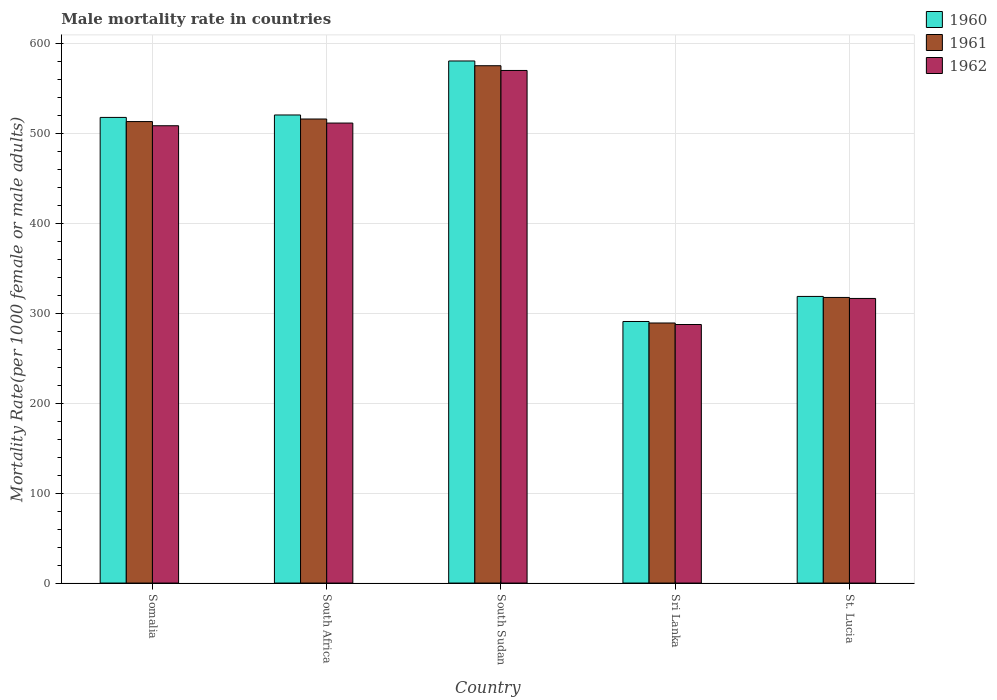How many different coloured bars are there?
Your answer should be very brief. 3. How many groups of bars are there?
Make the answer very short. 5. Are the number of bars on each tick of the X-axis equal?
Offer a very short reply. Yes. What is the label of the 5th group of bars from the left?
Your response must be concise. St. Lucia. In how many cases, is the number of bars for a given country not equal to the number of legend labels?
Make the answer very short. 0. What is the male mortality rate in 1960 in Somalia?
Your answer should be very brief. 517.62. Across all countries, what is the maximum male mortality rate in 1961?
Ensure brevity in your answer.  575.08. Across all countries, what is the minimum male mortality rate in 1962?
Provide a short and direct response. 287.41. In which country was the male mortality rate in 1961 maximum?
Make the answer very short. South Sudan. In which country was the male mortality rate in 1960 minimum?
Your response must be concise. Sri Lanka. What is the total male mortality rate in 1961 in the graph?
Offer a terse response. 2210.49. What is the difference between the male mortality rate in 1960 in South Sudan and that in Sri Lanka?
Your answer should be very brief. 289.59. What is the difference between the male mortality rate in 1960 in South Sudan and the male mortality rate in 1961 in Somalia?
Provide a succinct answer. 67.36. What is the average male mortality rate in 1961 per country?
Keep it short and to the point. 442.1. What is the difference between the male mortality rate of/in 1960 and male mortality rate of/in 1962 in Sri Lanka?
Your answer should be very brief. 3.35. What is the ratio of the male mortality rate in 1960 in Somalia to that in St. Lucia?
Ensure brevity in your answer.  1.62. Is the difference between the male mortality rate in 1960 in South Sudan and Sri Lanka greater than the difference between the male mortality rate in 1962 in South Sudan and Sri Lanka?
Offer a very short reply. Yes. What is the difference between the highest and the second highest male mortality rate in 1962?
Keep it short and to the point. 61.46. What is the difference between the highest and the lowest male mortality rate in 1962?
Offer a terse response. 282.4. In how many countries, is the male mortality rate in 1962 greater than the average male mortality rate in 1962 taken over all countries?
Your answer should be compact. 3. Is the sum of the male mortality rate in 1960 in Somalia and South Africa greater than the maximum male mortality rate in 1961 across all countries?
Offer a terse response. Yes. What does the 1st bar from the right in St. Lucia represents?
Offer a terse response. 1962. Is it the case that in every country, the sum of the male mortality rate in 1961 and male mortality rate in 1962 is greater than the male mortality rate in 1960?
Provide a short and direct response. Yes. How many bars are there?
Offer a very short reply. 15. How many countries are there in the graph?
Keep it short and to the point. 5. What is the difference between two consecutive major ticks on the Y-axis?
Your response must be concise. 100. Are the values on the major ticks of Y-axis written in scientific E-notation?
Offer a very short reply. No. Does the graph contain any zero values?
Ensure brevity in your answer.  No. Where does the legend appear in the graph?
Keep it short and to the point. Top right. What is the title of the graph?
Provide a short and direct response. Male mortality rate in countries. Does "1971" appear as one of the legend labels in the graph?
Offer a terse response. No. What is the label or title of the Y-axis?
Give a very brief answer. Mortality Rate(per 1000 female or male adults). What is the Mortality Rate(per 1000 female or male adults) of 1960 in Somalia?
Make the answer very short. 517.62. What is the Mortality Rate(per 1000 female or male adults) of 1961 in Somalia?
Your answer should be compact. 512.99. What is the Mortality Rate(per 1000 female or male adults) of 1962 in Somalia?
Offer a very short reply. 508.35. What is the Mortality Rate(per 1000 female or male adults) in 1960 in South Africa?
Your response must be concise. 520.32. What is the Mortality Rate(per 1000 female or male adults) of 1961 in South Africa?
Your response must be concise. 515.84. What is the Mortality Rate(per 1000 female or male adults) in 1962 in South Africa?
Your answer should be very brief. 511.35. What is the Mortality Rate(per 1000 female or male adults) in 1960 in South Sudan?
Provide a short and direct response. 580.35. What is the Mortality Rate(per 1000 female or male adults) of 1961 in South Sudan?
Your answer should be compact. 575.08. What is the Mortality Rate(per 1000 female or male adults) of 1962 in South Sudan?
Make the answer very short. 569.81. What is the Mortality Rate(per 1000 female or male adults) in 1960 in Sri Lanka?
Provide a succinct answer. 290.76. What is the Mortality Rate(per 1000 female or male adults) of 1961 in Sri Lanka?
Offer a very short reply. 289.09. What is the Mortality Rate(per 1000 female or male adults) of 1962 in Sri Lanka?
Your answer should be compact. 287.41. What is the Mortality Rate(per 1000 female or male adults) in 1960 in St. Lucia?
Provide a succinct answer. 318.62. What is the Mortality Rate(per 1000 female or male adults) in 1961 in St. Lucia?
Offer a very short reply. 317.49. What is the Mortality Rate(per 1000 female or male adults) in 1962 in St. Lucia?
Give a very brief answer. 316.37. Across all countries, what is the maximum Mortality Rate(per 1000 female or male adults) in 1960?
Keep it short and to the point. 580.35. Across all countries, what is the maximum Mortality Rate(per 1000 female or male adults) of 1961?
Offer a very short reply. 575.08. Across all countries, what is the maximum Mortality Rate(per 1000 female or male adults) in 1962?
Ensure brevity in your answer.  569.81. Across all countries, what is the minimum Mortality Rate(per 1000 female or male adults) in 1960?
Offer a very short reply. 290.76. Across all countries, what is the minimum Mortality Rate(per 1000 female or male adults) of 1961?
Your answer should be very brief. 289.09. Across all countries, what is the minimum Mortality Rate(per 1000 female or male adults) in 1962?
Provide a short and direct response. 287.41. What is the total Mortality Rate(per 1000 female or male adults) of 1960 in the graph?
Keep it short and to the point. 2227.67. What is the total Mortality Rate(per 1000 female or male adults) of 1961 in the graph?
Your answer should be compact. 2210.49. What is the total Mortality Rate(per 1000 female or male adults) in 1962 in the graph?
Your response must be concise. 2193.3. What is the difference between the Mortality Rate(per 1000 female or male adults) in 1960 in Somalia and that in South Africa?
Keep it short and to the point. -2.69. What is the difference between the Mortality Rate(per 1000 female or male adults) in 1961 in Somalia and that in South Africa?
Make the answer very short. -2.85. What is the difference between the Mortality Rate(per 1000 female or male adults) of 1962 in Somalia and that in South Africa?
Your answer should be very brief. -3. What is the difference between the Mortality Rate(per 1000 female or male adults) of 1960 in Somalia and that in South Sudan?
Make the answer very short. -62.73. What is the difference between the Mortality Rate(per 1000 female or male adults) of 1961 in Somalia and that in South Sudan?
Make the answer very short. -62.09. What is the difference between the Mortality Rate(per 1000 female or male adults) of 1962 in Somalia and that in South Sudan?
Offer a very short reply. -61.46. What is the difference between the Mortality Rate(per 1000 female or male adults) in 1960 in Somalia and that in Sri Lanka?
Offer a very short reply. 226.86. What is the difference between the Mortality Rate(per 1000 female or male adults) of 1961 in Somalia and that in Sri Lanka?
Your response must be concise. 223.9. What is the difference between the Mortality Rate(per 1000 female or male adults) of 1962 in Somalia and that in Sri Lanka?
Your response must be concise. 220.94. What is the difference between the Mortality Rate(per 1000 female or male adults) in 1960 in Somalia and that in St. Lucia?
Your response must be concise. 199.01. What is the difference between the Mortality Rate(per 1000 female or male adults) of 1961 in Somalia and that in St. Lucia?
Ensure brevity in your answer.  195.5. What is the difference between the Mortality Rate(per 1000 female or male adults) of 1962 in Somalia and that in St. Lucia?
Give a very brief answer. 191.98. What is the difference between the Mortality Rate(per 1000 female or male adults) of 1960 in South Africa and that in South Sudan?
Keep it short and to the point. -60.03. What is the difference between the Mortality Rate(per 1000 female or male adults) in 1961 in South Africa and that in South Sudan?
Offer a terse response. -59.24. What is the difference between the Mortality Rate(per 1000 female or male adults) in 1962 in South Africa and that in South Sudan?
Provide a succinct answer. -58.45. What is the difference between the Mortality Rate(per 1000 female or male adults) of 1960 in South Africa and that in Sri Lanka?
Provide a short and direct response. 229.56. What is the difference between the Mortality Rate(per 1000 female or male adults) in 1961 in South Africa and that in Sri Lanka?
Offer a terse response. 226.75. What is the difference between the Mortality Rate(per 1000 female or male adults) in 1962 in South Africa and that in Sri Lanka?
Make the answer very short. 223.94. What is the difference between the Mortality Rate(per 1000 female or male adults) in 1960 in South Africa and that in St. Lucia?
Your response must be concise. 201.7. What is the difference between the Mortality Rate(per 1000 female or male adults) of 1961 in South Africa and that in St. Lucia?
Make the answer very short. 198.34. What is the difference between the Mortality Rate(per 1000 female or male adults) in 1962 in South Africa and that in St. Lucia?
Keep it short and to the point. 194.98. What is the difference between the Mortality Rate(per 1000 female or male adults) of 1960 in South Sudan and that in Sri Lanka?
Your answer should be compact. 289.59. What is the difference between the Mortality Rate(per 1000 female or male adults) in 1961 in South Sudan and that in Sri Lanka?
Keep it short and to the point. 285.99. What is the difference between the Mortality Rate(per 1000 female or male adults) of 1962 in South Sudan and that in Sri Lanka?
Provide a short and direct response. 282.4. What is the difference between the Mortality Rate(per 1000 female or male adults) of 1960 in South Sudan and that in St. Lucia?
Offer a terse response. 261.74. What is the difference between the Mortality Rate(per 1000 female or male adults) of 1961 in South Sudan and that in St. Lucia?
Your answer should be compact. 257.59. What is the difference between the Mortality Rate(per 1000 female or male adults) of 1962 in South Sudan and that in St. Lucia?
Offer a very short reply. 253.44. What is the difference between the Mortality Rate(per 1000 female or male adults) of 1960 in Sri Lanka and that in St. Lucia?
Your response must be concise. -27.85. What is the difference between the Mortality Rate(per 1000 female or male adults) in 1961 in Sri Lanka and that in St. Lucia?
Keep it short and to the point. -28.4. What is the difference between the Mortality Rate(per 1000 female or male adults) of 1962 in Sri Lanka and that in St. Lucia?
Your answer should be compact. -28.96. What is the difference between the Mortality Rate(per 1000 female or male adults) in 1960 in Somalia and the Mortality Rate(per 1000 female or male adults) in 1961 in South Africa?
Ensure brevity in your answer.  1.79. What is the difference between the Mortality Rate(per 1000 female or male adults) of 1960 in Somalia and the Mortality Rate(per 1000 female or male adults) of 1962 in South Africa?
Offer a terse response. 6.27. What is the difference between the Mortality Rate(per 1000 female or male adults) in 1961 in Somalia and the Mortality Rate(per 1000 female or male adults) in 1962 in South Africa?
Your response must be concise. 1.63. What is the difference between the Mortality Rate(per 1000 female or male adults) in 1960 in Somalia and the Mortality Rate(per 1000 female or male adults) in 1961 in South Sudan?
Provide a short and direct response. -57.46. What is the difference between the Mortality Rate(per 1000 female or male adults) of 1960 in Somalia and the Mortality Rate(per 1000 female or male adults) of 1962 in South Sudan?
Offer a very short reply. -52.19. What is the difference between the Mortality Rate(per 1000 female or male adults) of 1961 in Somalia and the Mortality Rate(per 1000 female or male adults) of 1962 in South Sudan?
Offer a terse response. -56.82. What is the difference between the Mortality Rate(per 1000 female or male adults) in 1960 in Somalia and the Mortality Rate(per 1000 female or male adults) in 1961 in Sri Lanka?
Provide a short and direct response. 228.54. What is the difference between the Mortality Rate(per 1000 female or male adults) in 1960 in Somalia and the Mortality Rate(per 1000 female or male adults) in 1962 in Sri Lanka?
Your answer should be compact. 230.21. What is the difference between the Mortality Rate(per 1000 female or male adults) of 1961 in Somalia and the Mortality Rate(per 1000 female or male adults) of 1962 in Sri Lanka?
Make the answer very short. 225.57. What is the difference between the Mortality Rate(per 1000 female or male adults) in 1960 in Somalia and the Mortality Rate(per 1000 female or male adults) in 1961 in St. Lucia?
Keep it short and to the point. 200.13. What is the difference between the Mortality Rate(per 1000 female or male adults) in 1960 in Somalia and the Mortality Rate(per 1000 female or male adults) in 1962 in St. Lucia?
Offer a very short reply. 201.25. What is the difference between the Mortality Rate(per 1000 female or male adults) of 1961 in Somalia and the Mortality Rate(per 1000 female or male adults) of 1962 in St. Lucia?
Make the answer very short. 196.62. What is the difference between the Mortality Rate(per 1000 female or male adults) in 1960 in South Africa and the Mortality Rate(per 1000 female or male adults) in 1961 in South Sudan?
Give a very brief answer. -54.76. What is the difference between the Mortality Rate(per 1000 female or male adults) in 1960 in South Africa and the Mortality Rate(per 1000 female or male adults) in 1962 in South Sudan?
Make the answer very short. -49.49. What is the difference between the Mortality Rate(per 1000 female or male adults) of 1961 in South Africa and the Mortality Rate(per 1000 female or male adults) of 1962 in South Sudan?
Your answer should be very brief. -53.97. What is the difference between the Mortality Rate(per 1000 female or male adults) of 1960 in South Africa and the Mortality Rate(per 1000 female or male adults) of 1961 in Sri Lanka?
Offer a terse response. 231.23. What is the difference between the Mortality Rate(per 1000 female or male adults) of 1960 in South Africa and the Mortality Rate(per 1000 female or male adults) of 1962 in Sri Lanka?
Your answer should be very brief. 232.91. What is the difference between the Mortality Rate(per 1000 female or male adults) in 1961 in South Africa and the Mortality Rate(per 1000 female or male adults) in 1962 in Sri Lanka?
Your response must be concise. 228.42. What is the difference between the Mortality Rate(per 1000 female or male adults) of 1960 in South Africa and the Mortality Rate(per 1000 female or male adults) of 1961 in St. Lucia?
Offer a very short reply. 202.83. What is the difference between the Mortality Rate(per 1000 female or male adults) of 1960 in South Africa and the Mortality Rate(per 1000 female or male adults) of 1962 in St. Lucia?
Offer a terse response. 203.95. What is the difference between the Mortality Rate(per 1000 female or male adults) in 1961 in South Africa and the Mortality Rate(per 1000 female or male adults) in 1962 in St. Lucia?
Ensure brevity in your answer.  199.47. What is the difference between the Mortality Rate(per 1000 female or male adults) of 1960 in South Sudan and the Mortality Rate(per 1000 female or male adults) of 1961 in Sri Lanka?
Provide a succinct answer. 291.26. What is the difference between the Mortality Rate(per 1000 female or male adults) in 1960 in South Sudan and the Mortality Rate(per 1000 female or male adults) in 1962 in Sri Lanka?
Ensure brevity in your answer.  292.94. What is the difference between the Mortality Rate(per 1000 female or male adults) in 1961 in South Sudan and the Mortality Rate(per 1000 female or male adults) in 1962 in Sri Lanka?
Make the answer very short. 287.67. What is the difference between the Mortality Rate(per 1000 female or male adults) in 1960 in South Sudan and the Mortality Rate(per 1000 female or male adults) in 1961 in St. Lucia?
Your answer should be very brief. 262.86. What is the difference between the Mortality Rate(per 1000 female or male adults) in 1960 in South Sudan and the Mortality Rate(per 1000 female or male adults) in 1962 in St. Lucia?
Provide a short and direct response. 263.98. What is the difference between the Mortality Rate(per 1000 female or male adults) in 1961 in South Sudan and the Mortality Rate(per 1000 female or male adults) in 1962 in St. Lucia?
Make the answer very short. 258.71. What is the difference between the Mortality Rate(per 1000 female or male adults) of 1960 in Sri Lanka and the Mortality Rate(per 1000 female or male adults) of 1961 in St. Lucia?
Make the answer very short. -26.73. What is the difference between the Mortality Rate(per 1000 female or male adults) in 1960 in Sri Lanka and the Mortality Rate(per 1000 female or male adults) in 1962 in St. Lucia?
Give a very brief answer. -25.61. What is the difference between the Mortality Rate(per 1000 female or male adults) in 1961 in Sri Lanka and the Mortality Rate(per 1000 female or male adults) in 1962 in St. Lucia?
Your answer should be very brief. -27.28. What is the average Mortality Rate(per 1000 female or male adults) of 1960 per country?
Offer a very short reply. 445.53. What is the average Mortality Rate(per 1000 female or male adults) in 1961 per country?
Give a very brief answer. 442.1. What is the average Mortality Rate(per 1000 female or male adults) in 1962 per country?
Keep it short and to the point. 438.66. What is the difference between the Mortality Rate(per 1000 female or male adults) in 1960 and Mortality Rate(per 1000 female or male adults) in 1961 in Somalia?
Provide a succinct answer. 4.64. What is the difference between the Mortality Rate(per 1000 female or male adults) of 1960 and Mortality Rate(per 1000 female or male adults) of 1962 in Somalia?
Your answer should be very brief. 9.27. What is the difference between the Mortality Rate(per 1000 female or male adults) in 1961 and Mortality Rate(per 1000 female or male adults) in 1962 in Somalia?
Your answer should be compact. 4.64. What is the difference between the Mortality Rate(per 1000 female or male adults) of 1960 and Mortality Rate(per 1000 female or male adults) of 1961 in South Africa?
Ensure brevity in your answer.  4.48. What is the difference between the Mortality Rate(per 1000 female or male adults) in 1960 and Mortality Rate(per 1000 female or male adults) in 1962 in South Africa?
Make the answer very short. 8.96. What is the difference between the Mortality Rate(per 1000 female or male adults) of 1961 and Mortality Rate(per 1000 female or male adults) of 1962 in South Africa?
Provide a short and direct response. 4.48. What is the difference between the Mortality Rate(per 1000 female or male adults) in 1960 and Mortality Rate(per 1000 female or male adults) in 1961 in South Sudan?
Make the answer very short. 5.27. What is the difference between the Mortality Rate(per 1000 female or male adults) of 1960 and Mortality Rate(per 1000 female or male adults) of 1962 in South Sudan?
Provide a succinct answer. 10.54. What is the difference between the Mortality Rate(per 1000 female or male adults) in 1961 and Mortality Rate(per 1000 female or male adults) in 1962 in South Sudan?
Your response must be concise. 5.27. What is the difference between the Mortality Rate(per 1000 female or male adults) of 1960 and Mortality Rate(per 1000 female or male adults) of 1961 in Sri Lanka?
Ensure brevity in your answer.  1.68. What is the difference between the Mortality Rate(per 1000 female or male adults) in 1960 and Mortality Rate(per 1000 female or male adults) in 1962 in Sri Lanka?
Keep it short and to the point. 3.35. What is the difference between the Mortality Rate(per 1000 female or male adults) in 1961 and Mortality Rate(per 1000 female or male adults) in 1962 in Sri Lanka?
Ensure brevity in your answer.  1.68. What is the difference between the Mortality Rate(per 1000 female or male adults) of 1960 and Mortality Rate(per 1000 female or male adults) of 1961 in St. Lucia?
Offer a terse response. 1.12. What is the difference between the Mortality Rate(per 1000 female or male adults) in 1960 and Mortality Rate(per 1000 female or male adults) in 1962 in St. Lucia?
Make the answer very short. 2.24. What is the difference between the Mortality Rate(per 1000 female or male adults) in 1961 and Mortality Rate(per 1000 female or male adults) in 1962 in St. Lucia?
Keep it short and to the point. 1.12. What is the ratio of the Mortality Rate(per 1000 female or male adults) in 1961 in Somalia to that in South Africa?
Your response must be concise. 0.99. What is the ratio of the Mortality Rate(per 1000 female or male adults) of 1960 in Somalia to that in South Sudan?
Ensure brevity in your answer.  0.89. What is the ratio of the Mortality Rate(per 1000 female or male adults) in 1961 in Somalia to that in South Sudan?
Your answer should be compact. 0.89. What is the ratio of the Mortality Rate(per 1000 female or male adults) in 1962 in Somalia to that in South Sudan?
Ensure brevity in your answer.  0.89. What is the ratio of the Mortality Rate(per 1000 female or male adults) in 1960 in Somalia to that in Sri Lanka?
Your response must be concise. 1.78. What is the ratio of the Mortality Rate(per 1000 female or male adults) of 1961 in Somalia to that in Sri Lanka?
Your answer should be compact. 1.77. What is the ratio of the Mortality Rate(per 1000 female or male adults) of 1962 in Somalia to that in Sri Lanka?
Offer a very short reply. 1.77. What is the ratio of the Mortality Rate(per 1000 female or male adults) of 1960 in Somalia to that in St. Lucia?
Offer a very short reply. 1.62. What is the ratio of the Mortality Rate(per 1000 female or male adults) in 1961 in Somalia to that in St. Lucia?
Offer a very short reply. 1.62. What is the ratio of the Mortality Rate(per 1000 female or male adults) of 1962 in Somalia to that in St. Lucia?
Your answer should be compact. 1.61. What is the ratio of the Mortality Rate(per 1000 female or male adults) in 1960 in South Africa to that in South Sudan?
Give a very brief answer. 0.9. What is the ratio of the Mortality Rate(per 1000 female or male adults) of 1961 in South Africa to that in South Sudan?
Ensure brevity in your answer.  0.9. What is the ratio of the Mortality Rate(per 1000 female or male adults) in 1962 in South Africa to that in South Sudan?
Give a very brief answer. 0.9. What is the ratio of the Mortality Rate(per 1000 female or male adults) of 1960 in South Africa to that in Sri Lanka?
Make the answer very short. 1.79. What is the ratio of the Mortality Rate(per 1000 female or male adults) of 1961 in South Africa to that in Sri Lanka?
Make the answer very short. 1.78. What is the ratio of the Mortality Rate(per 1000 female or male adults) in 1962 in South Africa to that in Sri Lanka?
Provide a succinct answer. 1.78. What is the ratio of the Mortality Rate(per 1000 female or male adults) in 1960 in South Africa to that in St. Lucia?
Offer a terse response. 1.63. What is the ratio of the Mortality Rate(per 1000 female or male adults) of 1961 in South Africa to that in St. Lucia?
Keep it short and to the point. 1.62. What is the ratio of the Mortality Rate(per 1000 female or male adults) in 1962 in South Africa to that in St. Lucia?
Offer a terse response. 1.62. What is the ratio of the Mortality Rate(per 1000 female or male adults) of 1960 in South Sudan to that in Sri Lanka?
Provide a short and direct response. 2. What is the ratio of the Mortality Rate(per 1000 female or male adults) in 1961 in South Sudan to that in Sri Lanka?
Give a very brief answer. 1.99. What is the ratio of the Mortality Rate(per 1000 female or male adults) in 1962 in South Sudan to that in Sri Lanka?
Your response must be concise. 1.98. What is the ratio of the Mortality Rate(per 1000 female or male adults) of 1960 in South Sudan to that in St. Lucia?
Keep it short and to the point. 1.82. What is the ratio of the Mortality Rate(per 1000 female or male adults) in 1961 in South Sudan to that in St. Lucia?
Offer a terse response. 1.81. What is the ratio of the Mortality Rate(per 1000 female or male adults) of 1962 in South Sudan to that in St. Lucia?
Offer a terse response. 1.8. What is the ratio of the Mortality Rate(per 1000 female or male adults) of 1960 in Sri Lanka to that in St. Lucia?
Offer a very short reply. 0.91. What is the ratio of the Mortality Rate(per 1000 female or male adults) of 1961 in Sri Lanka to that in St. Lucia?
Give a very brief answer. 0.91. What is the ratio of the Mortality Rate(per 1000 female or male adults) in 1962 in Sri Lanka to that in St. Lucia?
Your answer should be compact. 0.91. What is the difference between the highest and the second highest Mortality Rate(per 1000 female or male adults) of 1960?
Ensure brevity in your answer.  60.03. What is the difference between the highest and the second highest Mortality Rate(per 1000 female or male adults) of 1961?
Ensure brevity in your answer.  59.24. What is the difference between the highest and the second highest Mortality Rate(per 1000 female or male adults) in 1962?
Offer a terse response. 58.45. What is the difference between the highest and the lowest Mortality Rate(per 1000 female or male adults) of 1960?
Your answer should be very brief. 289.59. What is the difference between the highest and the lowest Mortality Rate(per 1000 female or male adults) of 1961?
Provide a succinct answer. 285.99. What is the difference between the highest and the lowest Mortality Rate(per 1000 female or male adults) in 1962?
Keep it short and to the point. 282.4. 